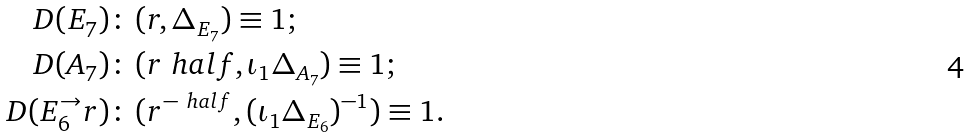<formula> <loc_0><loc_0><loc_500><loc_500>D ( E _ { 7 } ) \colon & \, ( r , \Delta _ { E _ { 7 } } ) \equiv 1 ; \\ D ( A _ { 7 } ) \colon & \, ( r ^ { \ } h a l f , \iota _ { 1 } \Delta _ { A _ { 7 } } ) \equiv 1 ; \\ D ( E _ { 6 } ^ { \to } r ) \colon & \, ( r ^ { - \ h a l f } , ( \iota _ { 1 } \Delta _ { E _ { 6 } } ) ^ { - 1 } ) \equiv 1 .</formula> 